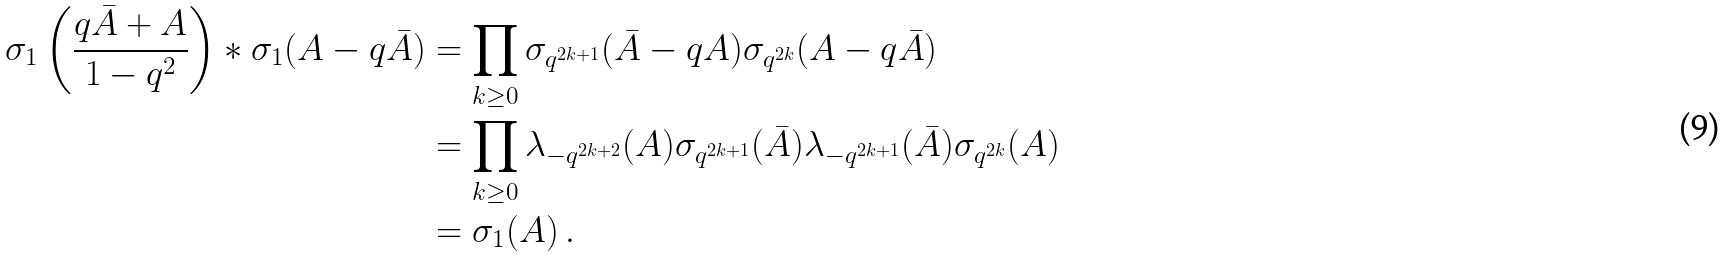Convert formula to latex. <formula><loc_0><loc_0><loc_500><loc_500>\sigma _ { 1 } \left ( \frac { q \bar { A } + A } { 1 - q ^ { 2 } } \right ) * \sigma _ { 1 } ( A - q \bar { A } ) & = \prod _ { k \geq 0 } \sigma _ { q ^ { 2 k + 1 } } ( \bar { A } - q A ) \sigma _ { q ^ { 2 k } } ( A - q \bar { A } ) \\ & = \prod _ { k \geq 0 } \lambda _ { - q ^ { 2 k + 2 } } ( A ) \sigma _ { q ^ { 2 k + 1 } } ( \bar { A } ) \lambda _ { - q ^ { 2 k + 1 } } ( \bar { A } ) \sigma _ { q ^ { 2 k } } ( A ) \\ & = \sigma _ { 1 } ( A ) \, .</formula> 